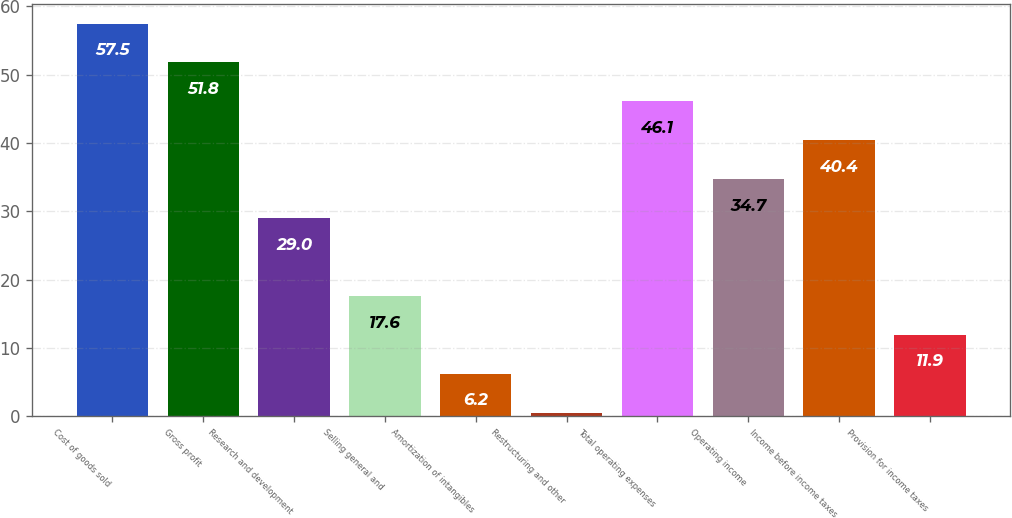<chart> <loc_0><loc_0><loc_500><loc_500><bar_chart><fcel>Cost of goods sold<fcel>Gross profit<fcel>Research and development<fcel>Selling general and<fcel>Amortization of intangibles<fcel>Restructuring and other<fcel>Total operating expenses<fcel>Operating income<fcel>Income before income taxes<fcel>Provision for income taxes<nl><fcel>57.5<fcel>51.8<fcel>29<fcel>17.6<fcel>6.2<fcel>0.5<fcel>46.1<fcel>34.7<fcel>40.4<fcel>11.9<nl></chart> 